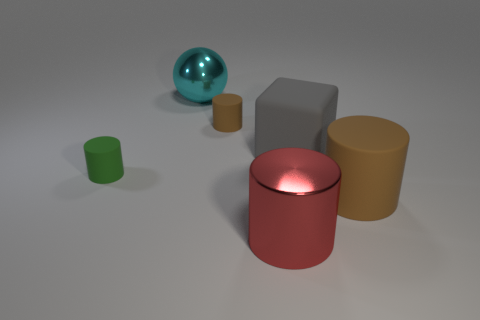Subtract all large brown cylinders. How many cylinders are left? 3 Subtract all red cubes. How many brown cylinders are left? 2 Add 3 green rubber objects. How many objects exist? 9 Subtract all green cylinders. How many cylinders are left? 3 Subtract all big red cylinders. Subtract all tiny brown rubber things. How many objects are left? 4 Add 3 matte cubes. How many matte cubes are left? 4 Add 6 brown rubber things. How many brown rubber things exist? 8 Subtract 0 gray balls. How many objects are left? 6 Subtract all cylinders. How many objects are left? 2 Subtract all brown cubes. Subtract all green cylinders. How many cubes are left? 1 